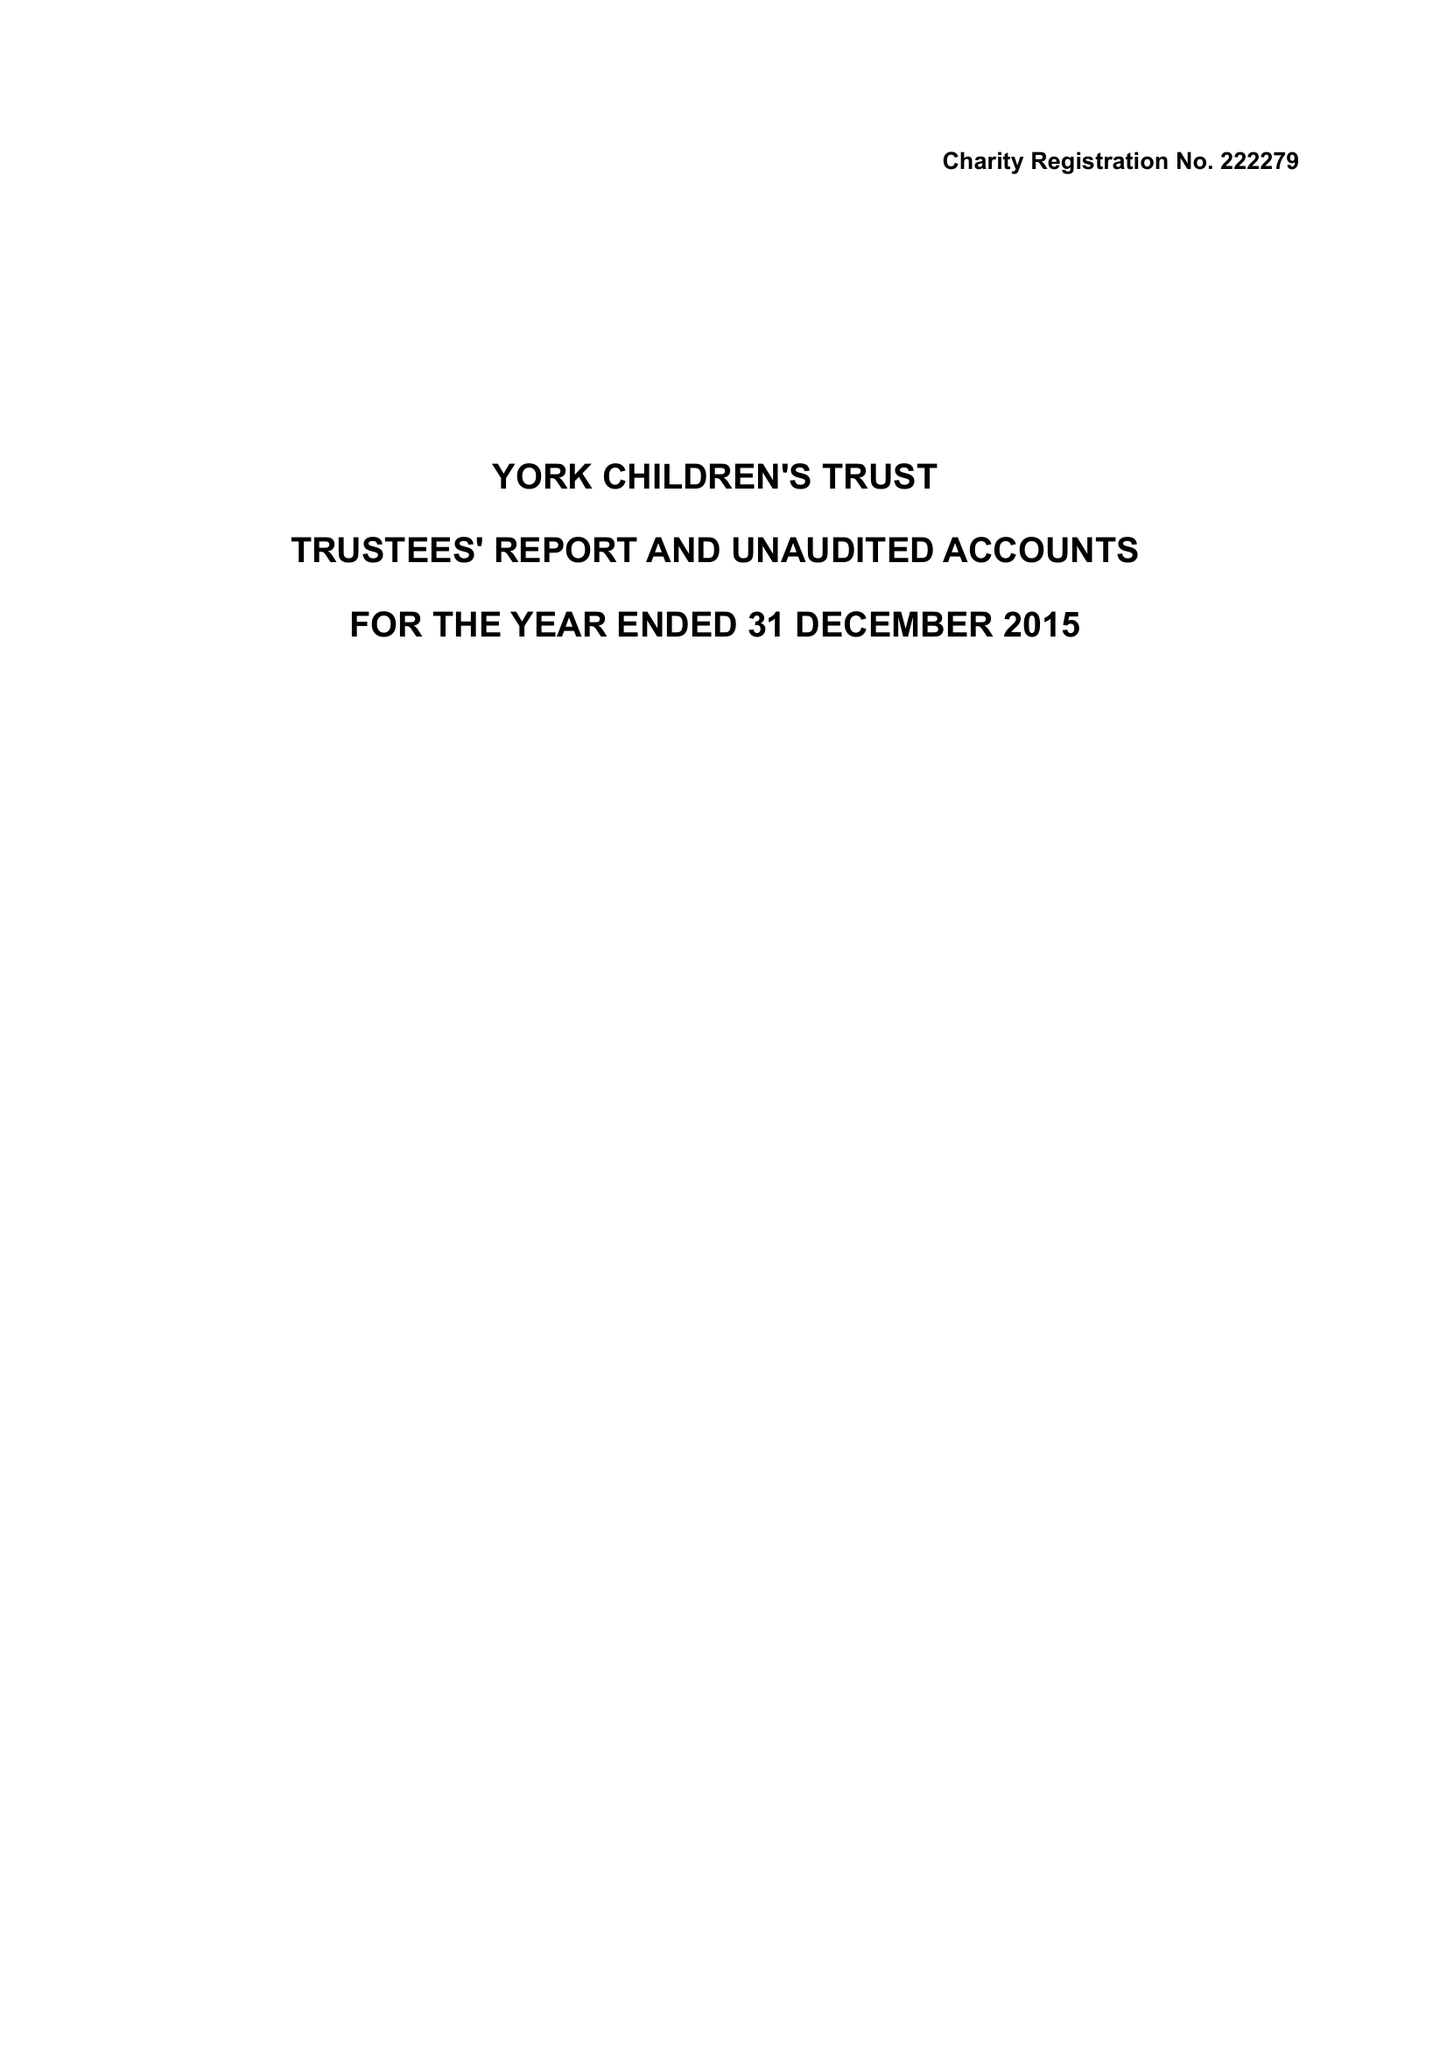What is the value for the address__postcode?
Answer the question using a single word or phrase. HG2 9LS 